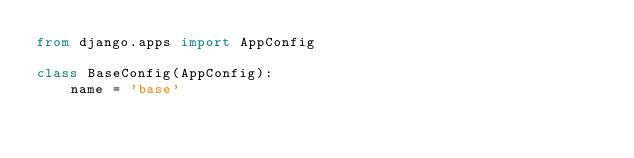Convert code to text. <code><loc_0><loc_0><loc_500><loc_500><_Python_>from django.apps import AppConfig

class BaseConfig(AppConfig):
    name = 'base'
</code> 